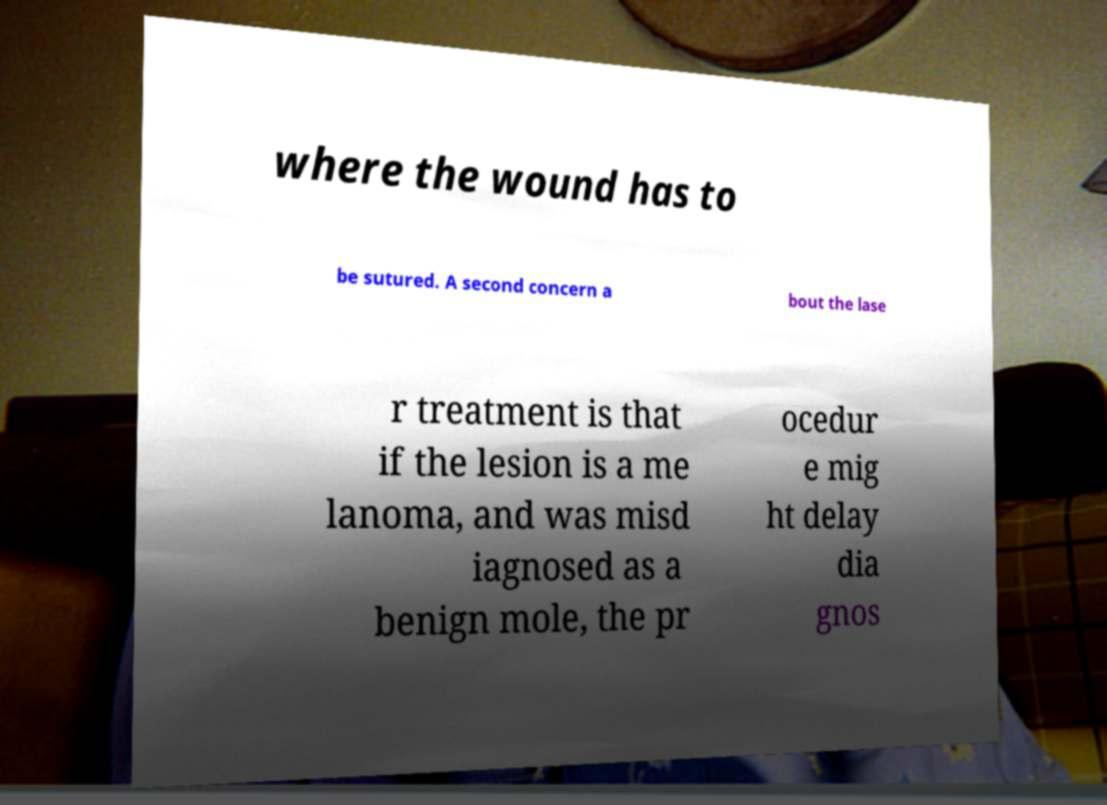There's text embedded in this image that I need extracted. Can you transcribe it verbatim? where the wound has to be sutured. A second concern a bout the lase r treatment is that if the lesion is a me lanoma, and was misd iagnosed as a benign mole, the pr ocedur e mig ht delay dia gnos 